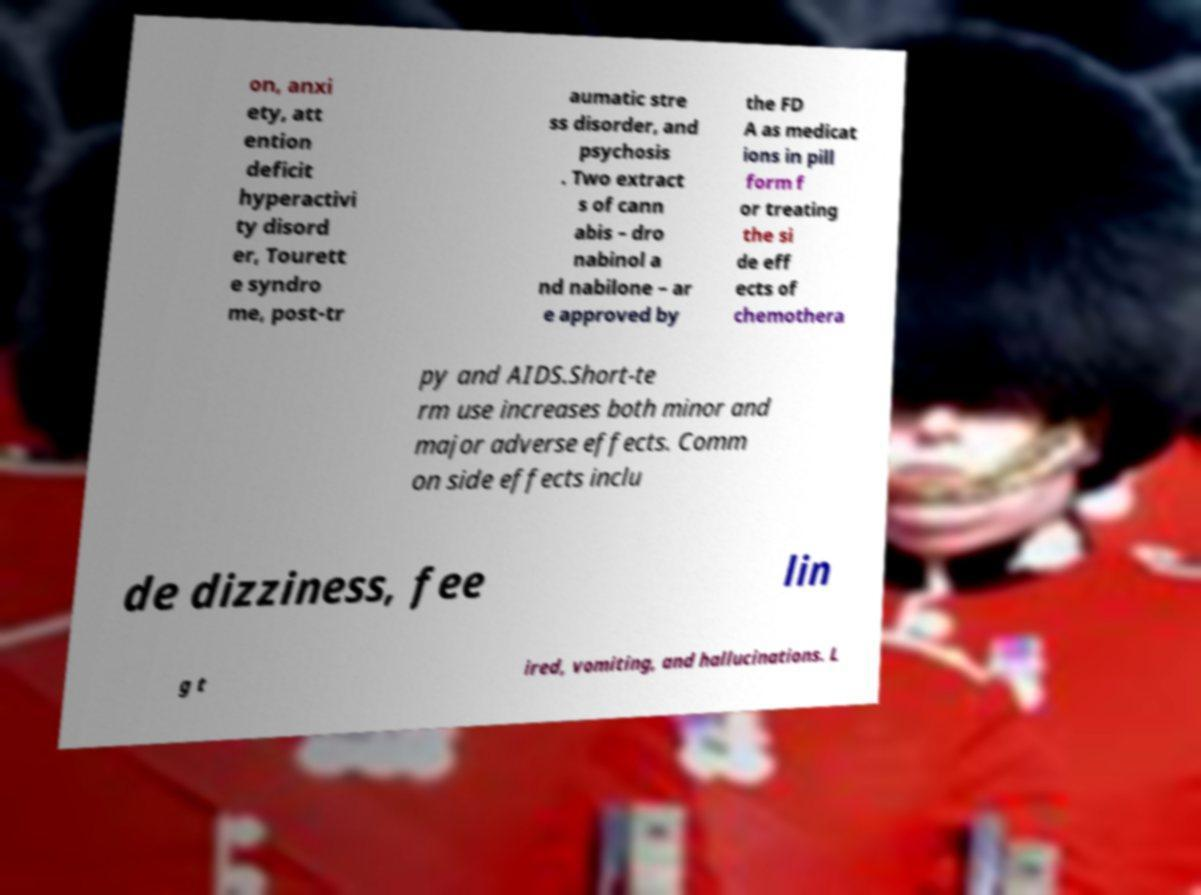What messages or text are displayed in this image? I need them in a readable, typed format. on, anxi ety, att ention deficit hyperactivi ty disord er, Tourett e syndro me, post-tr aumatic stre ss disorder, and psychosis . Two extract s of cann abis – dro nabinol a nd nabilone – ar e approved by the FD A as medicat ions in pill form f or treating the si de eff ects of chemothera py and AIDS.Short-te rm use increases both minor and major adverse effects. Comm on side effects inclu de dizziness, fee lin g t ired, vomiting, and hallucinations. L 